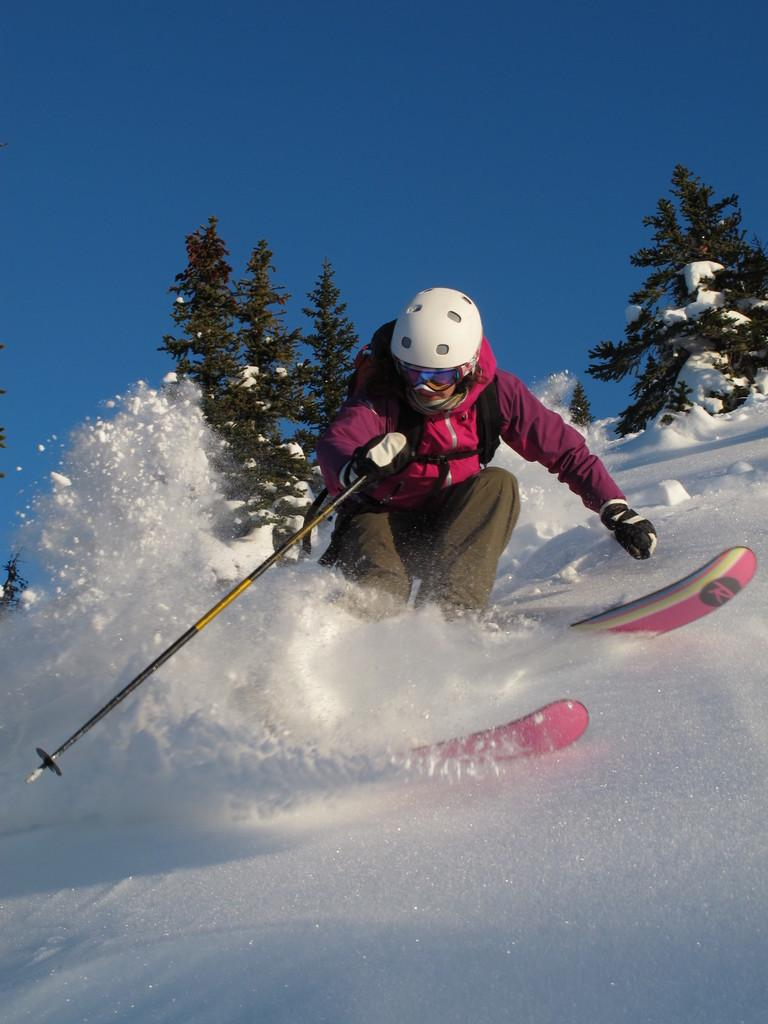Who is in the image? There is a person in the image. What is the person wearing on their head? The person is wearing a helmet. What is the person holding in their hand? The person is holding a stick in their hand. What activity is the person engaged in? The person is skiing on the snow. What can be seen in the background of the image? There is a group of trees and the sky visible in the background of the image. How many tails does the person have in the image? The person does not have any tails in the image. Who is the manager of the skiing team in the image? There is no indication of a skiing team or a manager in the image. 